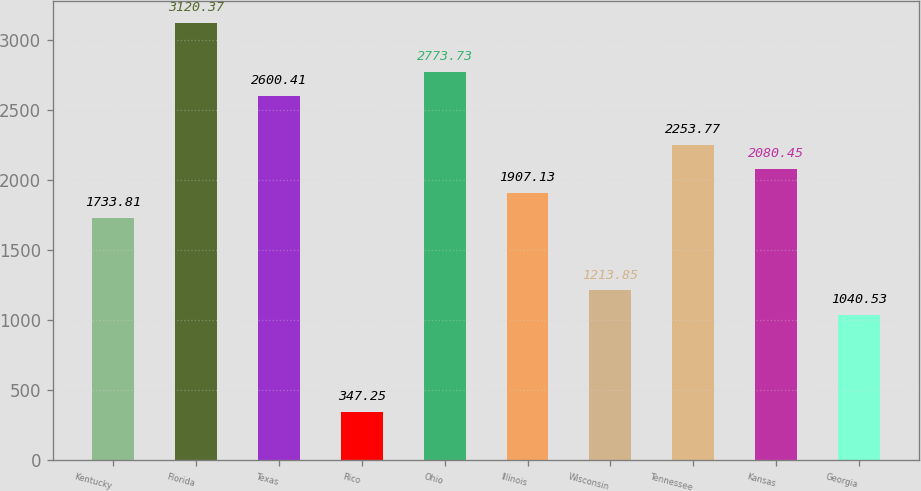Convert chart. <chart><loc_0><loc_0><loc_500><loc_500><bar_chart><fcel>Kentucky<fcel>Florida<fcel>Texas<fcel>Rico<fcel>Ohio<fcel>Illinois<fcel>Wisconsin<fcel>Tennessee<fcel>Kansas<fcel>Georgia<nl><fcel>1733.81<fcel>3120.37<fcel>2600.41<fcel>347.25<fcel>2773.73<fcel>1907.13<fcel>1213.85<fcel>2253.77<fcel>2080.45<fcel>1040.53<nl></chart> 